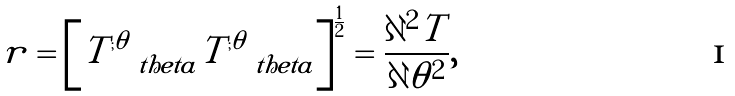<formula> <loc_0><loc_0><loc_500><loc_500>r = \left [ T _ { \quad t h e t a } ^ { ; \theta } T _ { \quad t h e t a } ^ { ; \theta } \right ] ^ { \frac { 1 } { 2 } } = \frac { \partial ^ { 2 } T } { \partial \theta ^ { 2 } } ,</formula> 